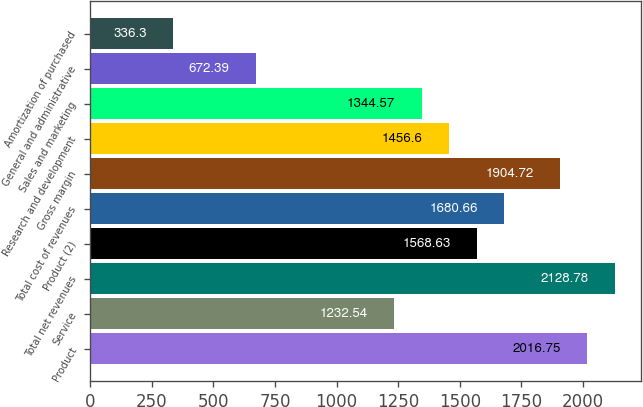Convert chart to OTSL. <chart><loc_0><loc_0><loc_500><loc_500><bar_chart><fcel>Product<fcel>Service<fcel>Total net revenues<fcel>Product (2)<fcel>Total cost of revenues<fcel>Gross margin<fcel>Research and development<fcel>Sales and marketing<fcel>General and administrative<fcel>Amortization of purchased<nl><fcel>2016.75<fcel>1232.54<fcel>2128.78<fcel>1568.63<fcel>1680.66<fcel>1904.72<fcel>1456.6<fcel>1344.57<fcel>672.39<fcel>336.3<nl></chart> 